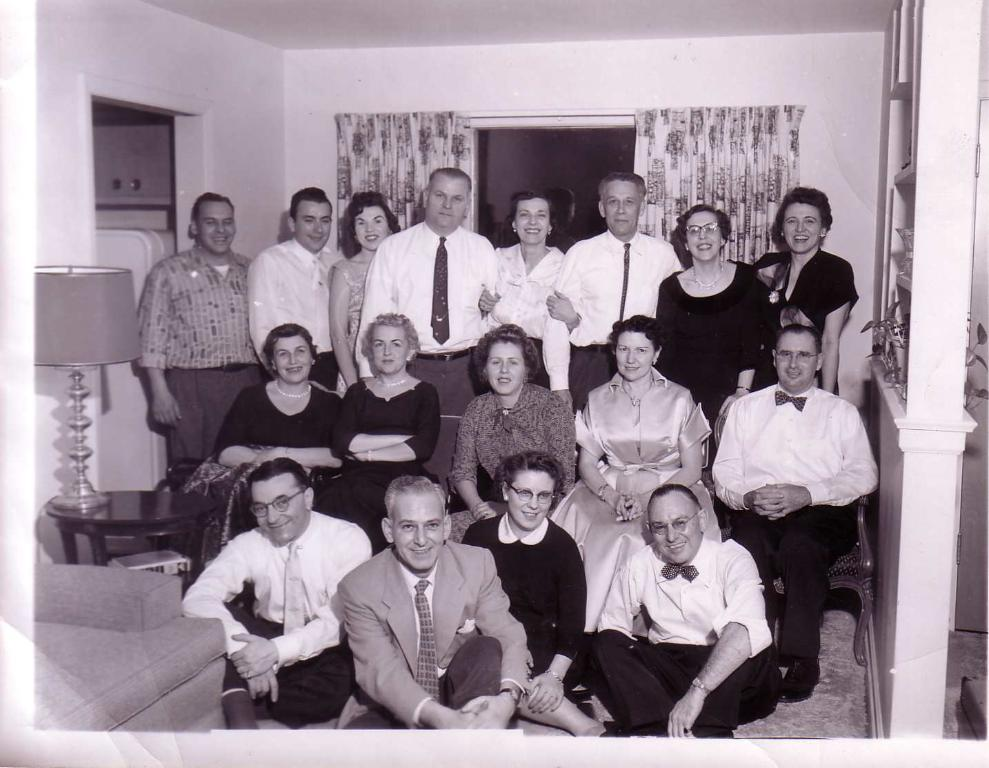How many people are in the image? There is a group of people in the image, but the exact number is not specified. What are the people in the image doing? Some people are standing, while others are sitting on the floor. What can be seen in the background of the image? There is a curtain and a wall in the image. What furniture is present in the image? There is a table in the image. What is on the table? There is a lamp on the table. Is there a net visible in the image? No, there is no net present in the image. What type of battle is taking place in the image? There is no battle depicted in the image; it features a group of people, some standing and others sitting on the floor, with a curtain, wall, table, and lamp in the background. 